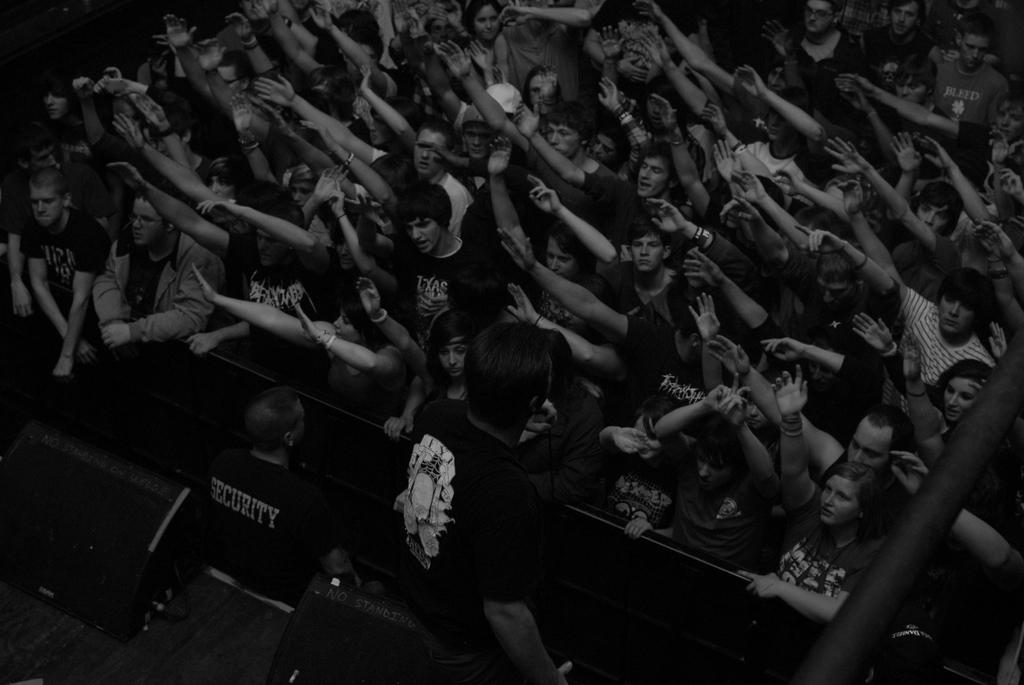What is the color scheme of the image? The image is black and white. What can be seen in the image? There is a crowd in the image. Where are the persons and speakers located in the image? The persons and speakers are at the bottom of the image. How many bats are hanging from the speakers in the image? There are no bats present in the image. What type of feather is being used as a decoration in the image? There is no feather present in the image. 